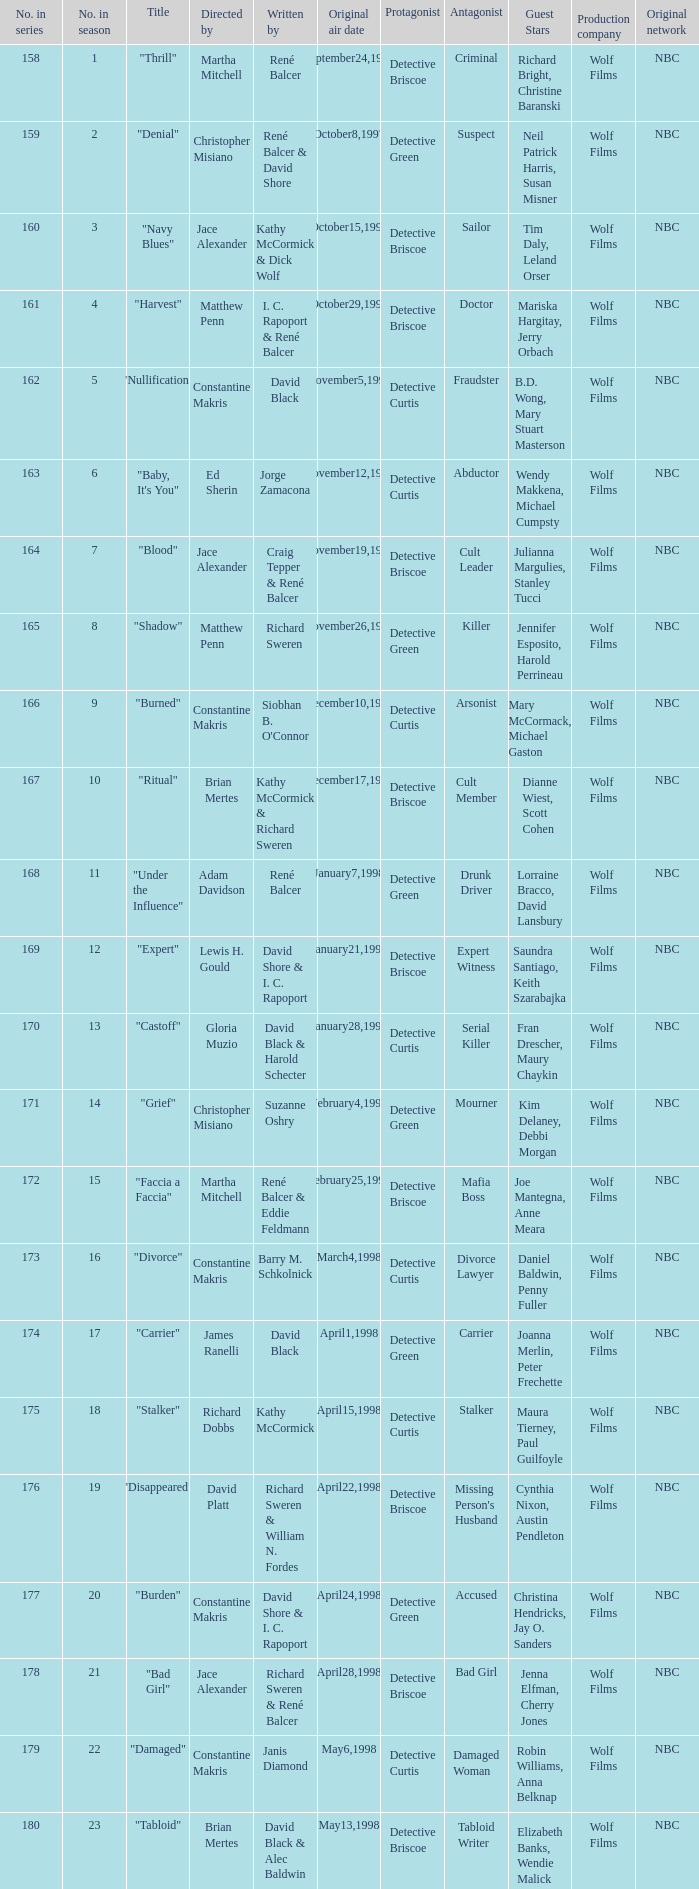Name the title of the episode that ed sherin directed. "Baby, It's You". 